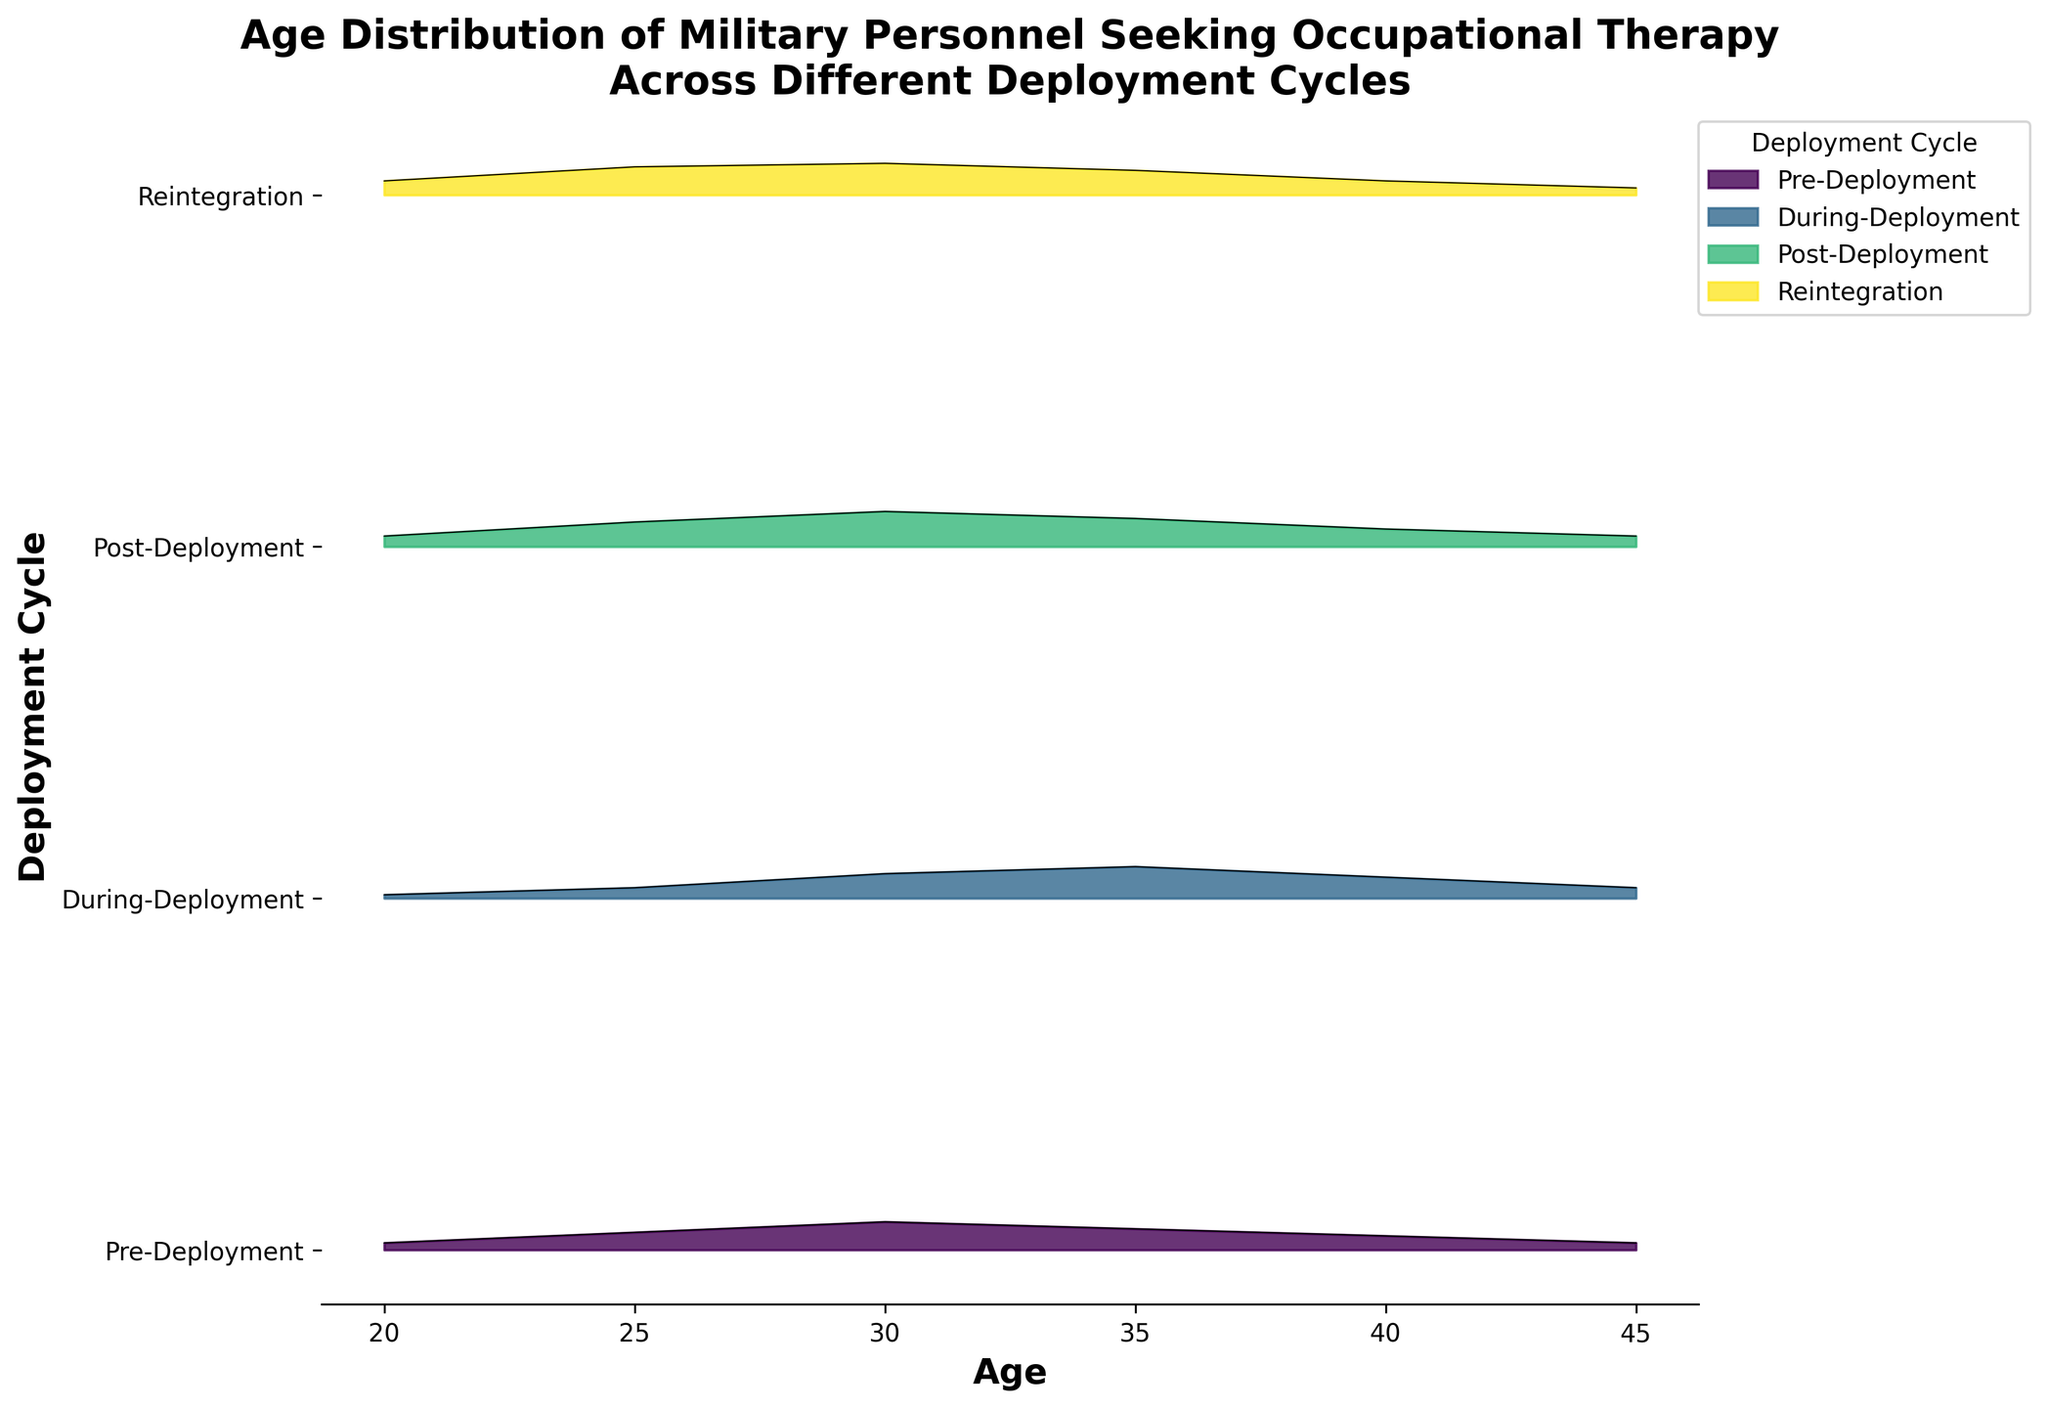What's the title of the figure? The title of the figure is usually placed at the top of the chart and is meant to give an overview of what the chart represents. Looking at the figure, the title is clearly labeled at the top.
Answer: Age Distribution of Military Personnel Seeking Occupational Therapy Across Different Deployment Cycles What does the x-axis represent? The x-axis is typically labeled to indicate what it measures. In this case, the x-axis is clearly labeled at the bottom of the chart.
Answer: Age What are the different deployment cycles shown on the y-axis? The y-axis labels indicate the different categories or groups being compared. These labels run alongside the ridgeline plots.
Answer: Pre-Deployment, During-Deployment, Post-Deployment, Reintegration Which deployment cycle shows the highest peak in age density? To determine this, one needs to look at the height of the peaks across the different ridgeline plots for each cycle. The highest peak will indicate the highest age density.
Answer: Post-Deployment How does the age distribution change from Pre-Deployment to During-Deployment? By comparing the ridgeline plots for Pre-Deployment and During-Deployment, one can observe the shifts in the peaks and the spread of the densities to understand the changes in age distribution.
Answer: The peak shifts slightly higher, and the density becomes broader during deployment During which deployment cycle is the density distribution of age most uniform? The uniformity of a distribution can be assessed by how spread out and flat the density appears. A less peaked and more spread out curve indicates more uniformity.
Answer: Reintegration Compare the age peaks between Post-Deployment and Reintegration. Which has a higher density at age 25? Comparing the height of the ridgeline plots at age 25 for both cycles will show which has a higher density at that age.
Answer: Reintegration What's the trend in age density as the cycles progress from Pre-Deployment to Reintegration? Observing the progression of the peaks and distributions from Pre-Deployment through to Reintegration helps identify trends in the age density patterns.
Answer: The peak density generally increases, with Post-Deployment being the highest, then slightly decreases during Reintegration In which cycle does the age density drop the most between ages 35 and 40? By examining the changes in the height of the ridgeline curves between ages 35 and 40 across all cycles, one can determine where the sharpest drop occurs.
Answer: During-Deployment Which deployment cycle has the narrowest age range with significant density? This can be assessed by looking at how spread out the ridgeline plots are for each cycle and identifying which one has a narrower range where the density is significant.
Answer: Pre-Deployment 